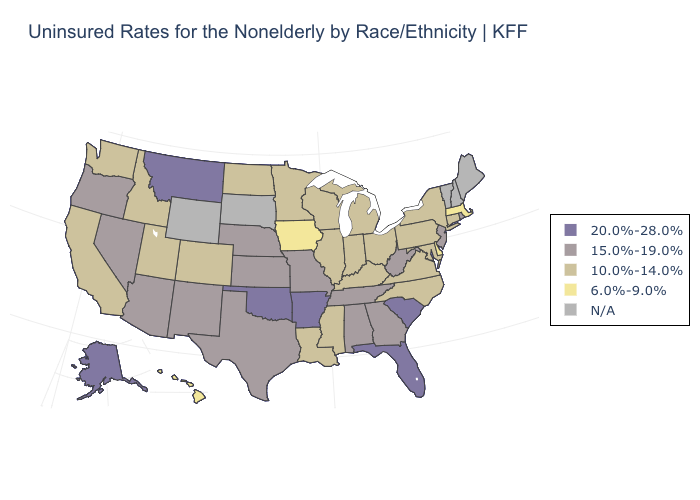What is the value of Virginia?
Short answer required. 10.0%-14.0%. What is the value of Kentucky?
Answer briefly. 10.0%-14.0%. Does the map have missing data?
Keep it brief. Yes. Does Rhode Island have the lowest value in the Northeast?
Write a very short answer. No. What is the value of Arizona?
Concise answer only. 15.0%-19.0%. What is the highest value in the West ?
Write a very short answer. 20.0%-28.0%. Does Delaware have the lowest value in the USA?
Be succinct. Yes. Is the legend a continuous bar?
Be succinct. No. Does Massachusetts have the lowest value in the Northeast?
Keep it brief. Yes. Does the map have missing data?
Answer briefly. Yes. What is the lowest value in states that border Arkansas?
Quick response, please. 10.0%-14.0%. Does Massachusetts have the lowest value in the USA?
Quick response, please. Yes. Does Massachusetts have the lowest value in the USA?
Give a very brief answer. Yes. What is the value of New York?
Keep it brief. 10.0%-14.0%. 